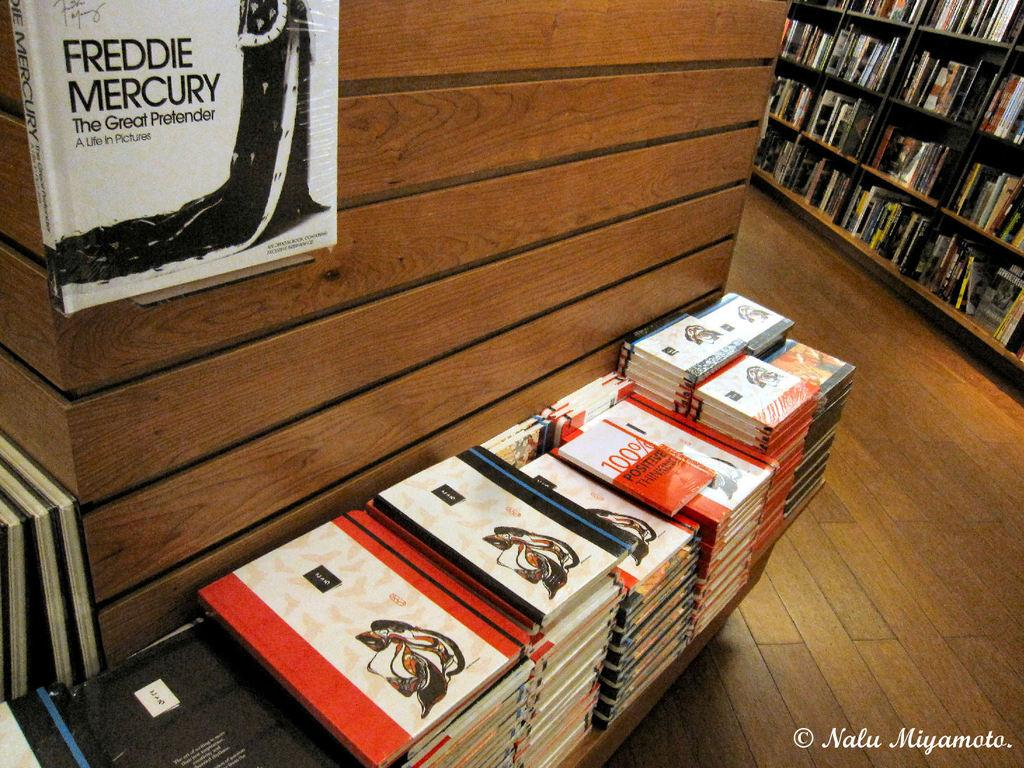<image>
Share a concise interpretation of the image provided. A book display in a book store with the top display book reading Freddie Mercury. 